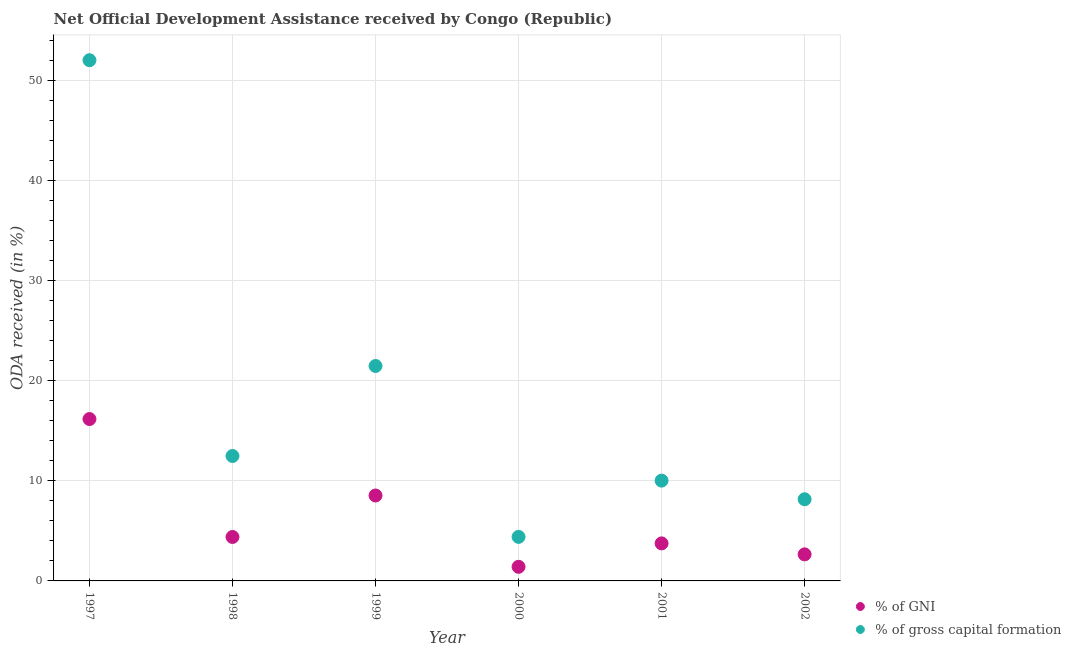How many different coloured dotlines are there?
Your answer should be compact. 2. What is the oda received as percentage of gross capital formation in 1997?
Give a very brief answer. 52.01. Across all years, what is the maximum oda received as percentage of gross capital formation?
Give a very brief answer. 52.01. Across all years, what is the minimum oda received as percentage of gni?
Your answer should be very brief. 1.41. In which year was the oda received as percentage of gni maximum?
Give a very brief answer. 1997. What is the total oda received as percentage of gross capital formation in the graph?
Ensure brevity in your answer.  108.53. What is the difference between the oda received as percentage of gni in 1997 and that in 2002?
Your response must be concise. 13.52. What is the difference between the oda received as percentage of gross capital formation in 1997 and the oda received as percentage of gni in 2002?
Your response must be concise. 49.36. What is the average oda received as percentage of gross capital formation per year?
Offer a terse response. 18.09. In the year 1998, what is the difference between the oda received as percentage of gni and oda received as percentage of gross capital formation?
Your answer should be very brief. -8.09. In how many years, is the oda received as percentage of gni greater than 50 %?
Your answer should be compact. 0. What is the ratio of the oda received as percentage of gni in 1997 to that in 2000?
Provide a short and direct response. 11.48. What is the difference between the highest and the second highest oda received as percentage of gross capital formation?
Ensure brevity in your answer.  30.54. What is the difference between the highest and the lowest oda received as percentage of gross capital formation?
Your answer should be compact. 47.61. In how many years, is the oda received as percentage of gni greater than the average oda received as percentage of gni taken over all years?
Your answer should be compact. 2. Is the sum of the oda received as percentage of gni in 1997 and 1998 greater than the maximum oda received as percentage of gross capital formation across all years?
Ensure brevity in your answer.  No. How many years are there in the graph?
Offer a very short reply. 6. Are the values on the major ticks of Y-axis written in scientific E-notation?
Ensure brevity in your answer.  No. Does the graph contain any zero values?
Your answer should be very brief. No. What is the title of the graph?
Your answer should be very brief. Net Official Development Assistance received by Congo (Republic). Does "Domestic liabilities" appear as one of the legend labels in the graph?
Make the answer very short. No. What is the label or title of the Y-axis?
Your response must be concise. ODA received (in %). What is the ODA received (in %) in % of GNI in 1997?
Your answer should be compact. 16.17. What is the ODA received (in %) of % of gross capital formation in 1997?
Provide a short and direct response. 52.01. What is the ODA received (in %) in % of GNI in 1998?
Offer a very short reply. 4.39. What is the ODA received (in %) in % of gross capital formation in 1998?
Give a very brief answer. 12.48. What is the ODA received (in %) in % of GNI in 1999?
Your answer should be compact. 8.53. What is the ODA received (in %) in % of gross capital formation in 1999?
Ensure brevity in your answer.  21.47. What is the ODA received (in %) in % of GNI in 2000?
Keep it short and to the point. 1.41. What is the ODA received (in %) in % of gross capital formation in 2000?
Your response must be concise. 4.4. What is the ODA received (in %) of % of GNI in 2001?
Keep it short and to the point. 3.75. What is the ODA received (in %) in % of gross capital formation in 2001?
Keep it short and to the point. 10.02. What is the ODA received (in %) of % of GNI in 2002?
Your response must be concise. 2.65. What is the ODA received (in %) in % of gross capital formation in 2002?
Give a very brief answer. 8.16. Across all years, what is the maximum ODA received (in %) of % of GNI?
Your answer should be compact. 16.17. Across all years, what is the maximum ODA received (in %) of % of gross capital formation?
Provide a short and direct response. 52.01. Across all years, what is the minimum ODA received (in %) in % of GNI?
Your response must be concise. 1.41. Across all years, what is the minimum ODA received (in %) in % of gross capital formation?
Keep it short and to the point. 4.4. What is the total ODA received (in %) of % of GNI in the graph?
Your answer should be compact. 36.9. What is the total ODA received (in %) in % of gross capital formation in the graph?
Your answer should be compact. 108.53. What is the difference between the ODA received (in %) of % of GNI in 1997 and that in 1998?
Offer a terse response. 11.78. What is the difference between the ODA received (in %) in % of gross capital formation in 1997 and that in 1998?
Provide a succinct answer. 39.53. What is the difference between the ODA received (in %) in % of GNI in 1997 and that in 1999?
Make the answer very short. 7.64. What is the difference between the ODA received (in %) in % of gross capital formation in 1997 and that in 1999?
Offer a terse response. 30.54. What is the difference between the ODA received (in %) in % of GNI in 1997 and that in 2000?
Provide a succinct answer. 14.76. What is the difference between the ODA received (in %) in % of gross capital formation in 1997 and that in 2000?
Give a very brief answer. 47.61. What is the difference between the ODA received (in %) in % of GNI in 1997 and that in 2001?
Your answer should be compact. 12.42. What is the difference between the ODA received (in %) of % of gross capital formation in 1997 and that in 2001?
Your answer should be very brief. 41.99. What is the difference between the ODA received (in %) in % of GNI in 1997 and that in 2002?
Offer a very short reply. 13.52. What is the difference between the ODA received (in %) in % of gross capital formation in 1997 and that in 2002?
Your answer should be compact. 43.85. What is the difference between the ODA received (in %) in % of GNI in 1998 and that in 1999?
Offer a very short reply. -4.14. What is the difference between the ODA received (in %) in % of gross capital formation in 1998 and that in 1999?
Give a very brief answer. -8.99. What is the difference between the ODA received (in %) in % of GNI in 1998 and that in 2000?
Ensure brevity in your answer.  2.98. What is the difference between the ODA received (in %) in % of gross capital formation in 1998 and that in 2000?
Keep it short and to the point. 8.08. What is the difference between the ODA received (in %) of % of GNI in 1998 and that in 2001?
Your response must be concise. 0.64. What is the difference between the ODA received (in %) in % of gross capital formation in 1998 and that in 2001?
Ensure brevity in your answer.  2.46. What is the difference between the ODA received (in %) of % of GNI in 1998 and that in 2002?
Provide a succinct answer. 1.74. What is the difference between the ODA received (in %) in % of gross capital formation in 1998 and that in 2002?
Keep it short and to the point. 4.32. What is the difference between the ODA received (in %) of % of GNI in 1999 and that in 2000?
Your answer should be very brief. 7.12. What is the difference between the ODA received (in %) in % of gross capital formation in 1999 and that in 2000?
Keep it short and to the point. 17.07. What is the difference between the ODA received (in %) of % of GNI in 1999 and that in 2001?
Keep it short and to the point. 4.78. What is the difference between the ODA received (in %) of % of gross capital formation in 1999 and that in 2001?
Give a very brief answer. 11.45. What is the difference between the ODA received (in %) of % of GNI in 1999 and that in 2002?
Keep it short and to the point. 5.88. What is the difference between the ODA received (in %) of % of gross capital formation in 1999 and that in 2002?
Provide a short and direct response. 13.31. What is the difference between the ODA received (in %) in % of GNI in 2000 and that in 2001?
Make the answer very short. -2.34. What is the difference between the ODA received (in %) of % of gross capital formation in 2000 and that in 2001?
Provide a short and direct response. -5.62. What is the difference between the ODA received (in %) of % of GNI in 2000 and that in 2002?
Your answer should be very brief. -1.24. What is the difference between the ODA received (in %) of % of gross capital formation in 2000 and that in 2002?
Provide a short and direct response. -3.76. What is the difference between the ODA received (in %) in % of GNI in 2001 and that in 2002?
Give a very brief answer. 1.1. What is the difference between the ODA received (in %) of % of gross capital formation in 2001 and that in 2002?
Give a very brief answer. 1.86. What is the difference between the ODA received (in %) in % of GNI in 1997 and the ODA received (in %) in % of gross capital formation in 1998?
Offer a very short reply. 3.69. What is the difference between the ODA received (in %) in % of GNI in 1997 and the ODA received (in %) in % of gross capital formation in 1999?
Ensure brevity in your answer.  -5.3. What is the difference between the ODA received (in %) of % of GNI in 1997 and the ODA received (in %) of % of gross capital formation in 2000?
Your response must be concise. 11.77. What is the difference between the ODA received (in %) of % of GNI in 1997 and the ODA received (in %) of % of gross capital formation in 2001?
Make the answer very short. 6.15. What is the difference between the ODA received (in %) of % of GNI in 1997 and the ODA received (in %) of % of gross capital formation in 2002?
Ensure brevity in your answer.  8.01. What is the difference between the ODA received (in %) in % of GNI in 1998 and the ODA received (in %) in % of gross capital formation in 1999?
Ensure brevity in your answer.  -17.08. What is the difference between the ODA received (in %) of % of GNI in 1998 and the ODA received (in %) of % of gross capital formation in 2000?
Offer a very short reply. -0.01. What is the difference between the ODA received (in %) of % of GNI in 1998 and the ODA received (in %) of % of gross capital formation in 2001?
Ensure brevity in your answer.  -5.63. What is the difference between the ODA received (in %) of % of GNI in 1998 and the ODA received (in %) of % of gross capital formation in 2002?
Keep it short and to the point. -3.77. What is the difference between the ODA received (in %) of % of GNI in 1999 and the ODA received (in %) of % of gross capital formation in 2000?
Ensure brevity in your answer.  4.13. What is the difference between the ODA received (in %) in % of GNI in 1999 and the ODA received (in %) in % of gross capital formation in 2001?
Ensure brevity in your answer.  -1.49. What is the difference between the ODA received (in %) of % of GNI in 1999 and the ODA received (in %) of % of gross capital formation in 2002?
Offer a very short reply. 0.38. What is the difference between the ODA received (in %) of % of GNI in 2000 and the ODA received (in %) of % of gross capital formation in 2001?
Give a very brief answer. -8.61. What is the difference between the ODA received (in %) in % of GNI in 2000 and the ODA received (in %) in % of gross capital formation in 2002?
Offer a terse response. -6.75. What is the difference between the ODA received (in %) of % of GNI in 2001 and the ODA received (in %) of % of gross capital formation in 2002?
Offer a terse response. -4.41. What is the average ODA received (in %) of % of GNI per year?
Ensure brevity in your answer.  6.15. What is the average ODA received (in %) in % of gross capital formation per year?
Your answer should be very brief. 18.09. In the year 1997, what is the difference between the ODA received (in %) of % of GNI and ODA received (in %) of % of gross capital formation?
Provide a succinct answer. -35.84. In the year 1998, what is the difference between the ODA received (in %) in % of GNI and ODA received (in %) in % of gross capital formation?
Provide a succinct answer. -8.09. In the year 1999, what is the difference between the ODA received (in %) in % of GNI and ODA received (in %) in % of gross capital formation?
Make the answer very short. -12.94. In the year 2000, what is the difference between the ODA received (in %) of % of GNI and ODA received (in %) of % of gross capital formation?
Offer a very short reply. -2.99. In the year 2001, what is the difference between the ODA received (in %) in % of GNI and ODA received (in %) in % of gross capital formation?
Offer a terse response. -6.27. In the year 2002, what is the difference between the ODA received (in %) of % of GNI and ODA received (in %) of % of gross capital formation?
Make the answer very short. -5.5. What is the ratio of the ODA received (in %) in % of GNI in 1997 to that in 1998?
Ensure brevity in your answer.  3.68. What is the ratio of the ODA received (in %) of % of gross capital formation in 1997 to that in 1998?
Offer a terse response. 4.17. What is the ratio of the ODA received (in %) in % of GNI in 1997 to that in 1999?
Offer a terse response. 1.9. What is the ratio of the ODA received (in %) in % of gross capital formation in 1997 to that in 1999?
Provide a short and direct response. 2.42. What is the ratio of the ODA received (in %) of % of GNI in 1997 to that in 2000?
Provide a succinct answer. 11.48. What is the ratio of the ODA received (in %) in % of gross capital formation in 1997 to that in 2000?
Your response must be concise. 11.83. What is the ratio of the ODA received (in %) in % of GNI in 1997 to that in 2001?
Your response must be concise. 4.31. What is the ratio of the ODA received (in %) of % of gross capital formation in 1997 to that in 2001?
Provide a short and direct response. 5.19. What is the ratio of the ODA received (in %) of % of GNI in 1997 to that in 2002?
Your answer should be compact. 6.09. What is the ratio of the ODA received (in %) in % of gross capital formation in 1997 to that in 2002?
Provide a succinct answer. 6.38. What is the ratio of the ODA received (in %) of % of GNI in 1998 to that in 1999?
Your response must be concise. 0.51. What is the ratio of the ODA received (in %) of % of gross capital formation in 1998 to that in 1999?
Make the answer very short. 0.58. What is the ratio of the ODA received (in %) in % of GNI in 1998 to that in 2000?
Offer a very short reply. 3.12. What is the ratio of the ODA received (in %) in % of gross capital formation in 1998 to that in 2000?
Keep it short and to the point. 2.84. What is the ratio of the ODA received (in %) in % of GNI in 1998 to that in 2001?
Make the answer very short. 1.17. What is the ratio of the ODA received (in %) in % of gross capital formation in 1998 to that in 2001?
Your answer should be compact. 1.25. What is the ratio of the ODA received (in %) of % of GNI in 1998 to that in 2002?
Ensure brevity in your answer.  1.65. What is the ratio of the ODA received (in %) of % of gross capital formation in 1998 to that in 2002?
Keep it short and to the point. 1.53. What is the ratio of the ODA received (in %) of % of GNI in 1999 to that in 2000?
Keep it short and to the point. 6.06. What is the ratio of the ODA received (in %) of % of gross capital formation in 1999 to that in 2000?
Give a very brief answer. 4.88. What is the ratio of the ODA received (in %) in % of GNI in 1999 to that in 2001?
Keep it short and to the point. 2.28. What is the ratio of the ODA received (in %) in % of gross capital formation in 1999 to that in 2001?
Keep it short and to the point. 2.14. What is the ratio of the ODA received (in %) in % of GNI in 1999 to that in 2002?
Keep it short and to the point. 3.22. What is the ratio of the ODA received (in %) of % of gross capital formation in 1999 to that in 2002?
Give a very brief answer. 2.63. What is the ratio of the ODA received (in %) of % of GNI in 2000 to that in 2001?
Your response must be concise. 0.38. What is the ratio of the ODA received (in %) of % of gross capital formation in 2000 to that in 2001?
Offer a terse response. 0.44. What is the ratio of the ODA received (in %) of % of GNI in 2000 to that in 2002?
Your response must be concise. 0.53. What is the ratio of the ODA received (in %) in % of gross capital formation in 2000 to that in 2002?
Make the answer very short. 0.54. What is the ratio of the ODA received (in %) of % of GNI in 2001 to that in 2002?
Provide a succinct answer. 1.41. What is the ratio of the ODA received (in %) in % of gross capital formation in 2001 to that in 2002?
Your response must be concise. 1.23. What is the difference between the highest and the second highest ODA received (in %) in % of GNI?
Offer a terse response. 7.64. What is the difference between the highest and the second highest ODA received (in %) in % of gross capital formation?
Offer a very short reply. 30.54. What is the difference between the highest and the lowest ODA received (in %) in % of GNI?
Offer a very short reply. 14.76. What is the difference between the highest and the lowest ODA received (in %) in % of gross capital formation?
Your response must be concise. 47.61. 